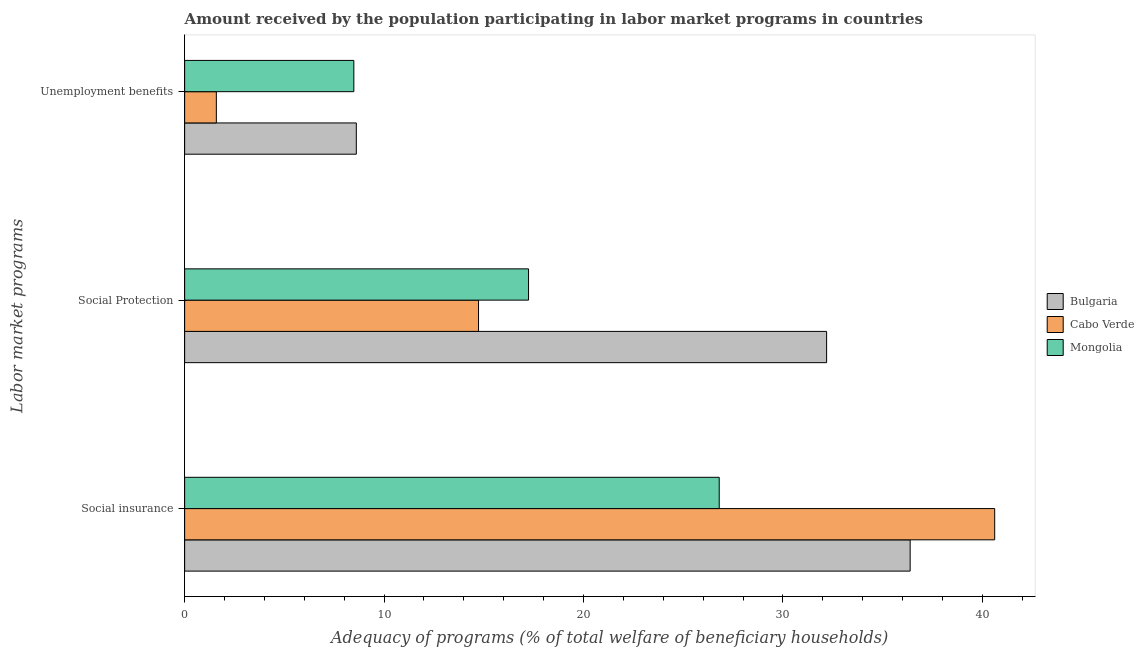How many different coloured bars are there?
Give a very brief answer. 3. How many groups of bars are there?
Provide a short and direct response. 3. How many bars are there on the 2nd tick from the bottom?
Your answer should be very brief. 3. What is the label of the 2nd group of bars from the top?
Keep it short and to the point. Social Protection. What is the amount received by the population participating in social insurance programs in Bulgaria?
Offer a terse response. 36.38. Across all countries, what is the maximum amount received by the population participating in social insurance programs?
Make the answer very short. 40.62. Across all countries, what is the minimum amount received by the population participating in social insurance programs?
Provide a short and direct response. 26.81. In which country was the amount received by the population participating in social insurance programs maximum?
Provide a succinct answer. Cabo Verde. In which country was the amount received by the population participating in unemployment benefits programs minimum?
Ensure brevity in your answer.  Cabo Verde. What is the total amount received by the population participating in social insurance programs in the graph?
Give a very brief answer. 103.81. What is the difference between the amount received by the population participating in social protection programs in Cabo Verde and that in Bulgaria?
Give a very brief answer. -17.45. What is the difference between the amount received by the population participating in social protection programs in Mongolia and the amount received by the population participating in unemployment benefits programs in Bulgaria?
Make the answer very short. 8.64. What is the average amount received by the population participating in social insurance programs per country?
Offer a very short reply. 34.6. What is the difference between the amount received by the population participating in social insurance programs and amount received by the population participating in social protection programs in Mongolia?
Ensure brevity in your answer.  9.56. What is the ratio of the amount received by the population participating in social insurance programs in Bulgaria to that in Mongolia?
Give a very brief answer. 1.36. Is the amount received by the population participating in social insurance programs in Cabo Verde less than that in Bulgaria?
Keep it short and to the point. No. What is the difference between the highest and the second highest amount received by the population participating in social insurance programs?
Your response must be concise. 4.24. What is the difference between the highest and the lowest amount received by the population participating in social insurance programs?
Provide a succinct answer. 13.81. What does the 2nd bar from the top in Social insurance represents?
Keep it short and to the point. Cabo Verde. What does the 2nd bar from the bottom in Social Protection represents?
Offer a terse response. Cabo Verde. How many countries are there in the graph?
Provide a short and direct response. 3. Does the graph contain any zero values?
Give a very brief answer. No. How are the legend labels stacked?
Keep it short and to the point. Vertical. What is the title of the graph?
Your response must be concise. Amount received by the population participating in labor market programs in countries. Does "Europe(developing only)" appear as one of the legend labels in the graph?
Give a very brief answer. No. What is the label or title of the X-axis?
Your response must be concise. Adequacy of programs (% of total welfare of beneficiary households). What is the label or title of the Y-axis?
Make the answer very short. Labor market programs. What is the Adequacy of programs (% of total welfare of beneficiary households) in Bulgaria in Social insurance?
Offer a terse response. 36.38. What is the Adequacy of programs (% of total welfare of beneficiary households) of Cabo Verde in Social insurance?
Provide a succinct answer. 40.62. What is the Adequacy of programs (% of total welfare of beneficiary households) of Mongolia in Social insurance?
Your answer should be compact. 26.81. What is the Adequacy of programs (% of total welfare of beneficiary households) in Bulgaria in Social Protection?
Your response must be concise. 32.19. What is the Adequacy of programs (% of total welfare of beneficiary households) in Cabo Verde in Social Protection?
Provide a short and direct response. 14.74. What is the Adequacy of programs (% of total welfare of beneficiary households) in Mongolia in Social Protection?
Your answer should be very brief. 17.25. What is the Adequacy of programs (% of total welfare of beneficiary households) of Bulgaria in Unemployment benefits?
Give a very brief answer. 8.61. What is the Adequacy of programs (% of total welfare of beneficiary households) in Cabo Verde in Unemployment benefits?
Provide a succinct answer. 1.59. What is the Adequacy of programs (% of total welfare of beneficiary households) of Mongolia in Unemployment benefits?
Your response must be concise. 8.48. Across all Labor market programs, what is the maximum Adequacy of programs (% of total welfare of beneficiary households) in Bulgaria?
Make the answer very short. 36.38. Across all Labor market programs, what is the maximum Adequacy of programs (% of total welfare of beneficiary households) of Cabo Verde?
Offer a terse response. 40.62. Across all Labor market programs, what is the maximum Adequacy of programs (% of total welfare of beneficiary households) in Mongolia?
Your response must be concise. 26.81. Across all Labor market programs, what is the minimum Adequacy of programs (% of total welfare of beneficiary households) in Bulgaria?
Offer a terse response. 8.61. Across all Labor market programs, what is the minimum Adequacy of programs (% of total welfare of beneficiary households) of Cabo Verde?
Give a very brief answer. 1.59. Across all Labor market programs, what is the minimum Adequacy of programs (% of total welfare of beneficiary households) in Mongolia?
Your response must be concise. 8.48. What is the total Adequacy of programs (% of total welfare of beneficiary households) of Bulgaria in the graph?
Your response must be concise. 77.18. What is the total Adequacy of programs (% of total welfare of beneficiary households) of Cabo Verde in the graph?
Provide a succinct answer. 56.95. What is the total Adequacy of programs (% of total welfare of beneficiary households) in Mongolia in the graph?
Ensure brevity in your answer.  52.54. What is the difference between the Adequacy of programs (% of total welfare of beneficiary households) of Bulgaria in Social insurance and that in Social Protection?
Keep it short and to the point. 4.19. What is the difference between the Adequacy of programs (% of total welfare of beneficiary households) of Cabo Verde in Social insurance and that in Social Protection?
Your answer should be very brief. 25.88. What is the difference between the Adequacy of programs (% of total welfare of beneficiary households) in Mongolia in Social insurance and that in Social Protection?
Ensure brevity in your answer.  9.56. What is the difference between the Adequacy of programs (% of total welfare of beneficiary households) in Bulgaria in Social insurance and that in Unemployment benefits?
Offer a terse response. 27.77. What is the difference between the Adequacy of programs (% of total welfare of beneficiary households) in Cabo Verde in Social insurance and that in Unemployment benefits?
Your answer should be compact. 39.03. What is the difference between the Adequacy of programs (% of total welfare of beneficiary households) of Mongolia in Social insurance and that in Unemployment benefits?
Your answer should be compact. 18.32. What is the difference between the Adequacy of programs (% of total welfare of beneficiary households) of Bulgaria in Social Protection and that in Unemployment benefits?
Keep it short and to the point. 23.58. What is the difference between the Adequacy of programs (% of total welfare of beneficiary households) in Cabo Verde in Social Protection and that in Unemployment benefits?
Offer a terse response. 13.15. What is the difference between the Adequacy of programs (% of total welfare of beneficiary households) of Mongolia in Social Protection and that in Unemployment benefits?
Provide a short and direct response. 8.76. What is the difference between the Adequacy of programs (% of total welfare of beneficiary households) of Bulgaria in Social insurance and the Adequacy of programs (% of total welfare of beneficiary households) of Cabo Verde in Social Protection?
Provide a succinct answer. 21.64. What is the difference between the Adequacy of programs (% of total welfare of beneficiary households) of Bulgaria in Social insurance and the Adequacy of programs (% of total welfare of beneficiary households) of Mongolia in Social Protection?
Offer a terse response. 19.14. What is the difference between the Adequacy of programs (% of total welfare of beneficiary households) in Cabo Verde in Social insurance and the Adequacy of programs (% of total welfare of beneficiary households) in Mongolia in Social Protection?
Your response must be concise. 23.38. What is the difference between the Adequacy of programs (% of total welfare of beneficiary households) in Bulgaria in Social insurance and the Adequacy of programs (% of total welfare of beneficiary households) in Cabo Verde in Unemployment benefits?
Your response must be concise. 34.79. What is the difference between the Adequacy of programs (% of total welfare of beneficiary households) in Bulgaria in Social insurance and the Adequacy of programs (% of total welfare of beneficiary households) in Mongolia in Unemployment benefits?
Your response must be concise. 27.9. What is the difference between the Adequacy of programs (% of total welfare of beneficiary households) of Cabo Verde in Social insurance and the Adequacy of programs (% of total welfare of beneficiary households) of Mongolia in Unemployment benefits?
Ensure brevity in your answer.  32.14. What is the difference between the Adequacy of programs (% of total welfare of beneficiary households) of Bulgaria in Social Protection and the Adequacy of programs (% of total welfare of beneficiary households) of Cabo Verde in Unemployment benefits?
Offer a terse response. 30.6. What is the difference between the Adequacy of programs (% of total welfare of beneficiary households) in Bulgaria in Social Protection and the Adequacy of programs (% of total welfare of beneficiary households) in Mongolia in Unemployment benefits?
Make the answer very short. 23.71. What is the difference between the Adequacy of programs (% of total welfare of beneficiary households) in Cabo Verde in Social Protection and the Adequacy of programs (% of total welfare of beneficiary households) in Mongolia in Unemployment benefits?
Ensure brevity in your answer.  6.25. What is the average Adequacy of programs (% of total welfare of beneficiary households) in Bulgaria per Labor market programs?
Make the answer very short. 25.73. What is the average Adequacy of programs (% of total welfare of beneficiary households) in Cabo Verde per Labor market programs?
Keep it short and to the point. 18.98. What is the average Adequacy of programs (% of total welfare of beneficiary households) in Mongolia per Labor market programs?
Your response must be concise. 17.51. What is the difference between the Adequacy of programs (% of total welfare of beneficiary households) in Bulgaria and Adequacy of programs (% of total welfare of beneficiary households) in Cabo Verde in Social insurance?
Keep it short and to the point. -4.24. What is the difference between the Adequacy of programs (% of total welfare of beneficiary households) of Bulgaria and Adequacy of programs (% of total welfare of beneficiary households) of Mongolia in Social insurance?
Keep it short and to the point. 9.57. What is the difference between the Adequacy of programs (% of total welfare of beneficiary households) of Cabo Verde and Adequacy of programs (% of total welfare of beneficiary households) of Mongolia in Social insurance?
Make the answer very short. 13.81. What is the difference between the Adequacy of programs (% of total welfare of beneficiary households) of Bulgaria and Adequacy of programs (% of total welfare of beneficiary households) of Cabo Verde in Social Protection?
Make the answer very short. 17.45. What is the difference between the Adequacy of programs (% of total welfare of beneficiary households) of Bulgaria and Adequacy of programs (% of total welfare of beneficiary households) of Mongolia in Social Protection?
Your answer should be very brief. 14.95. What is the difference between the Adequacy of programs (% of total welfare of beneficiary households) in Cabo Verde and Adequacy of programs (% of total welfare of beneficiary households) in Mongolia in Social Protection?
Provide a short and direct response. -2.51. What is the difference between the Adequacy of programs (% of total welfare of beneficiary households) in Bulgaria and Adequacy of programs (% of total welfare of beneficiary households) in Cabo Verde in Unemployment benefits?
Keep it short and to the point. 7.02. What is the difference between the Adequacy of programs (% of total welfare of beneficiary households) in Bulgaria and Adequacy of programs (% of total welfare of beneficiary households) in Mongolia in Unemployment benefits?
Your answer should be very brief. 0.12. What is the difference between the Adequacy of programs (% of total welfare of beneficiary households) of Cabo Verde and Adequacy of programs (% of total welfare of beneficiary households) of Mongolia in Unemployment benefits?
Offer a very short reply. -6.89. What is the ratio of the Adequacy of programs (% of total welfare of beneficiary households) of Bulgaria in Social insurance to that in Social Protection?
Make the answer very short. 1.13. What is the ratio of the Adequacy of programs (% of total welfare of beneficiary households) of Cabo Verde in Social insurance to that in Social Protection?
Offer a very short reply. 2.76. What is the ratio of the Adequacy of programs (% of total welfare of beneficiary households) of Mongolia in Social insurance to that in Social Protection?
Your answer should be very brief. 1.55. What is the ratio of the Adequacy of programs (% of total welfare of beneficiary households) of Bulgaria in Social insurance to that in Unemployment benefits?
Keep it short and to the point. 4.23. What is the ratio of the Adequacy of programs (% of total welfare of beneficiary households) of Cabo Verde in Social insurance to that in Unemployment benefits?
Offer a very short reply. 25.56. What is the ratio of the Adequacy of programs (% of total welfare of beneficiary households) in Mongolia in Social insurance to that in Unemployment benefits?
Your answer should be very brief. 3.16. What is the ratio of the Adequacy of programs (% of total welfare of beneficiary households) in Bulgaria in Social Protection to that in Unemployment benefits?
Your response must be concise. 3.74. What is the ratio of the Adequacy of programs (% of total welfare of beneficiary households) of Cabo Verde in Social Protection to that in Unemployment benefits?
Your answer should be very brief. 9.27. What is the ratio of the Adequacy of programs (% of total welfare of beneficiary households) in Mongolia in Social Protection to that in Unemployment benefits?
Make the answer very short. 2.03. What is the difference between the highest and the second highest Adequacy of programs (% of total welfare of beneficiary households) in Bulgaria?
Ensure brevity in your answer.  4.19. What is the difference between the highest and the second highest Adequacy of programs (% of total welfare of beneficiary households) of Cabo Verde?
Your response must be concise. 25.88. What is the difference between the highest and the second highest Adequacy of programs (% of total welfare of beneficiary households) in Mongolia?
Give a very brief answer. 9.56. What is the difference between the highest and the lowest Adequacy of programs (% of total welfare of beneficiary households) in Bulgaria?
Give a very brief answer. 27.77. What is the difference between the highest and the lowest Adequacy of programs (% of total welfare of beneficiary households) of Cabo Verde?
Offer a very short reply. 39.03. What is the difference between the highest and the lowest Adequacy of programs (% of total welfare of beneficiary households) of Mongolia?
Make the answer very short. 18.32. 